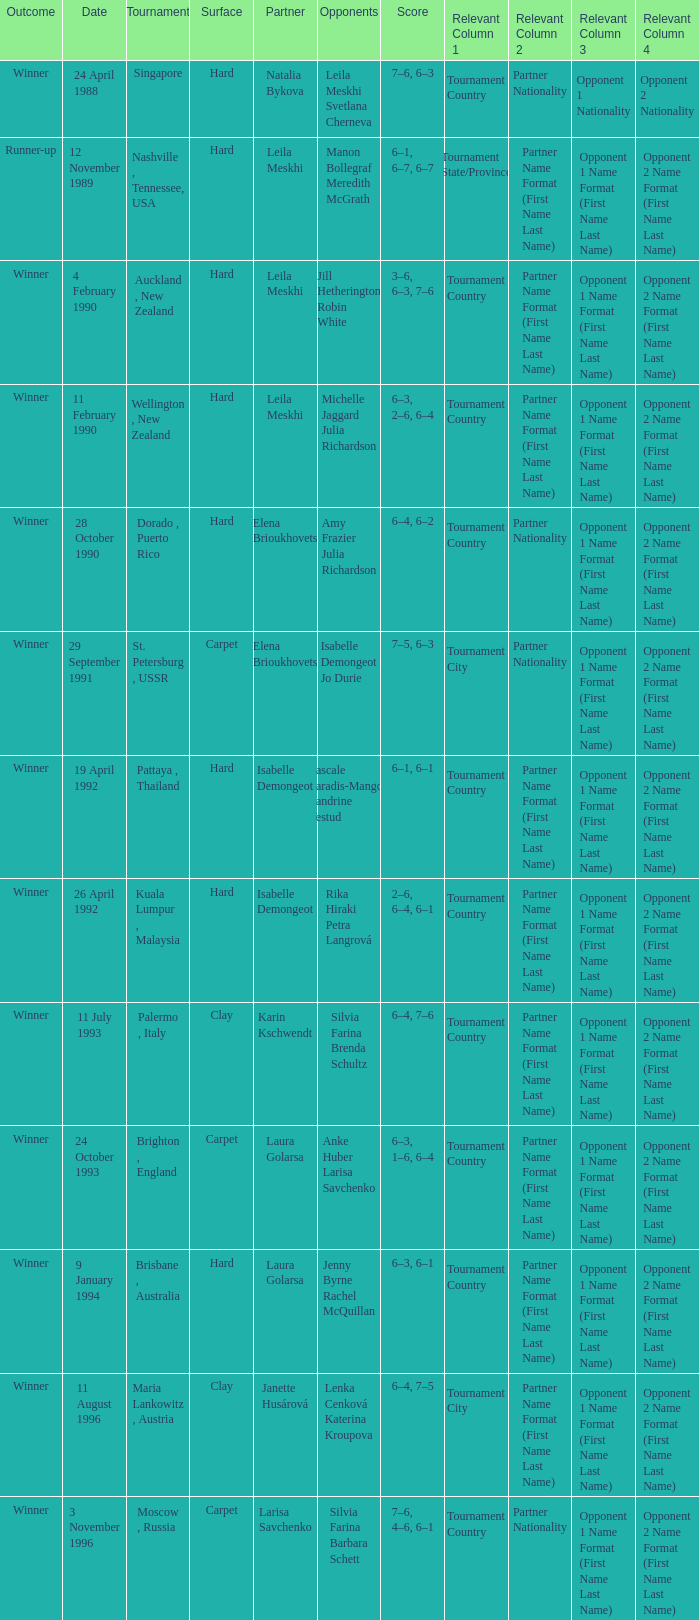On what Date was the Score 6–4, 6–2? 28 October 1990. 